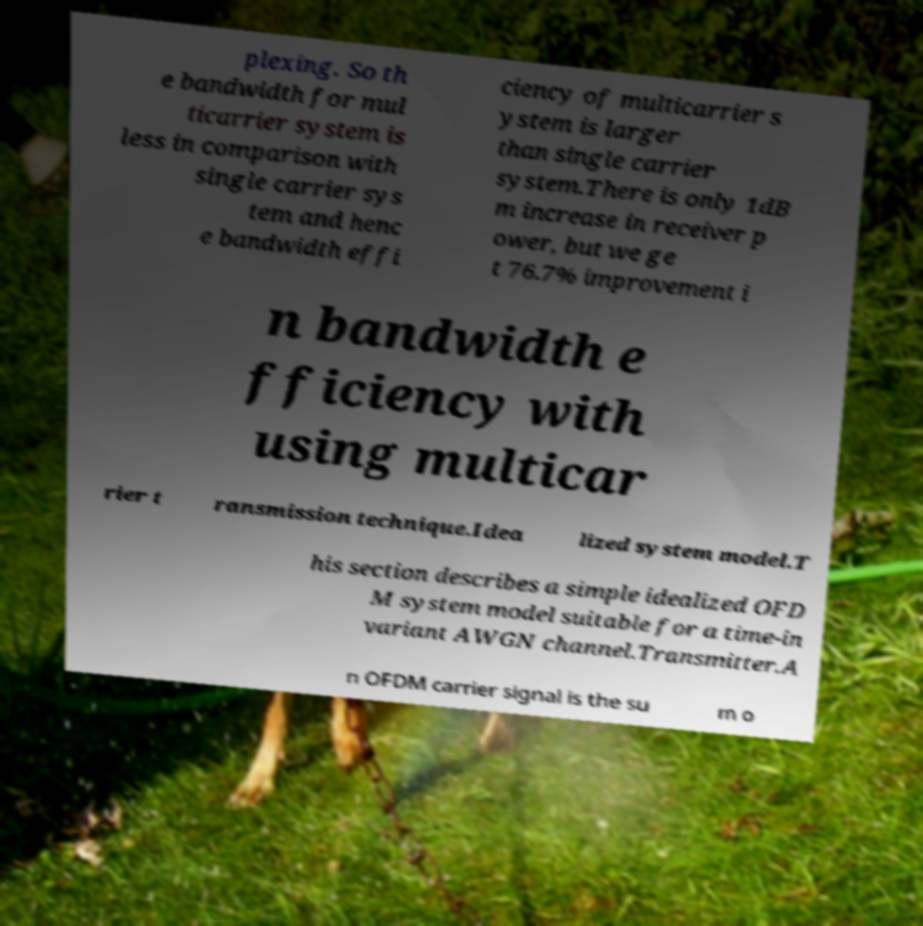I need the written content from this picture converted into text. Can you do that? plexing. So th e bandwidth for mul ticarrier system is less in comparison with single carrier sys tem and henc e bandwidth effi ciency of multicarrier s ystem is larger than single carrier system.There is only 1dB m increase in receiver p ower, but we ge t 76.7% improvement i n bandwidth e fficiency with using multicar rier t ransmission technique.Idea lized system model.T his section describes a simple idealized OFD M system model suitable for a time-in variant AWGN channel.Transmitter.A n OFDM carrier signal is the su m o 